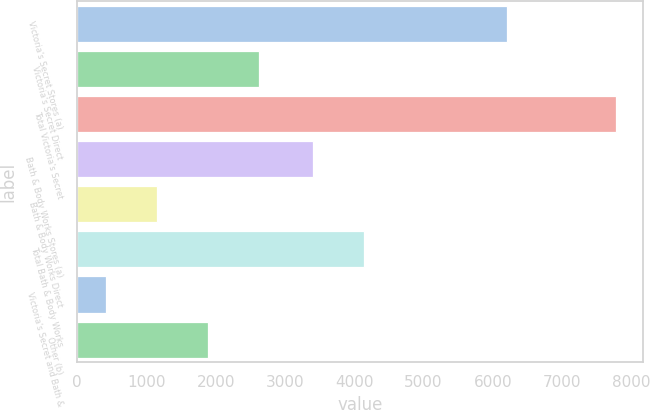Convert chart to OTSL. <chart><loc_0><loc_0><loc_500><loc_500><bar_chart><fcel>Victoria's Secret Stores (a)<fcel>Victoria's Secret Direct<fcel>Total Victoria's Secret<fcel>Bath & Body Works Stores (a)<fcel>Bath & Body Works Direct<fcel>Total Bath & Body Works<fcel>Victoria's Secret and Bath &<fcel>Other (b)<nl><fcel>6199<fcel>2630.4<fcel>7781<fcel>3400<fcel>1158.8<fcel>4135.8<fcel>423<fcel>1894.6<nl></chart> 